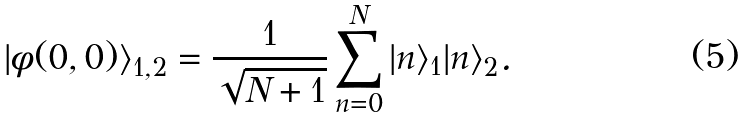Convert formula to latex. <formula><loc_0><loc_0><loc_500><loc_500>| \phi ( 0 , 0 ) \rangle _ { 1 , 2 } = \frac { 1 } { \sqrt { N + 1 } } \sum _ { n = 0 } ^ { N } | n \rangle _ { 1 } | n \rangle _ { 2 } .</formula> 